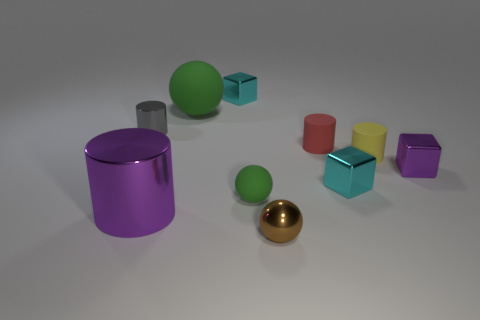Subtract all small balls. How many balls are left? 1 Subtract all gray blocks. How many green balls are left? 2 Subtract 1 cylinders. How many cylinders are left? 3 Subtract all red cylinders. How many cylinders are left? 3 Subtract all spheres. How many objects are left? 7 Subtract all red spheres. Subtract all yellow cylinders. How many spheres are left? 3 Subtract 0 brown cylinders. How many objects are left? 10 Subtract all large purple things. Subtract all small gray cylinders. How many objects are left? 8 Add 4 small yellow cylinders. How many small yellow cylinders are left? 5 Add 1 purple matte blocks. How many purple matte blocks exist? 1 